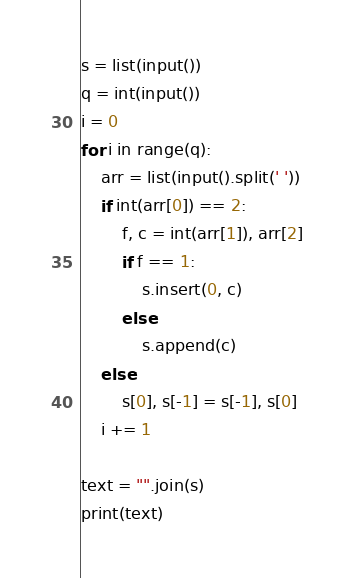Convert code to text. <code><loc_0><loc_0><loc_500><loc_500><_Python_>s = list(input())
q = int(input())
i = 0
for i in range(q):
    arr = list(input().split(' '))
    if int(arr[0]) == 2:
        f, c = int(arr[1]), arr[2]
        if f == 1:
            s.insert(0, c)
        else:
            s.append(c) 
    else:
        s[0], s[-1] = s[-1], s[0]
    i += 1

text = "".join(s)
print(text)</code> 